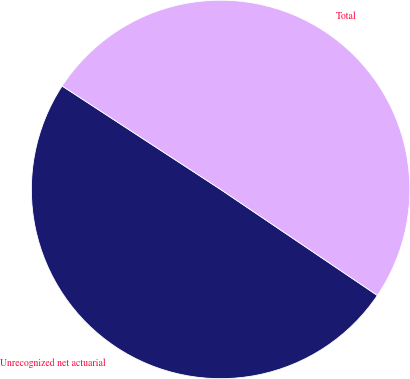<chart> <loc_0><loc_0><loc_500><loc_500><pie_chart><fcel>Unrecognized net actuarial<fcel>Total<nl><fcel>49.74%<fcel>50.26%<nl></chart> 